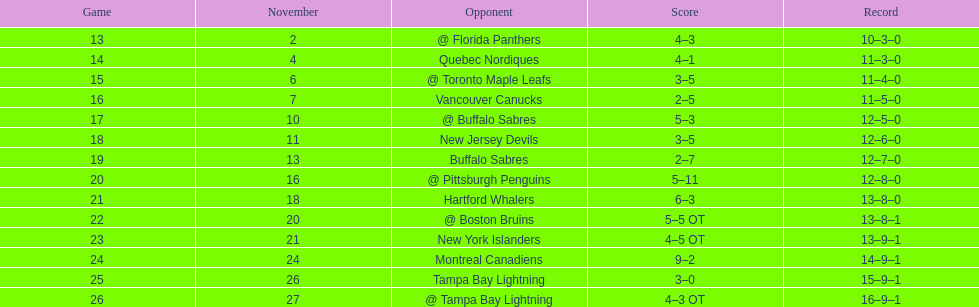The 1993-1994 flyers missed the playoffs again. how many consecutive seasons up until 93-94 did the flyers miss the playoffs? 5. Parse the table in full. {'header': ['Game', 'November', 'Opponent', 'Score', 'Record'], 'rows': [['13', '2', '@ Florida Panthers', '4–3', '10–3–0'], ['14', '4', 'Quebec Nordiques', '4–1', '11–3–0'], ['15', '6', '@ Toronto Maple Leafs', '3–5', '11–4–0'], ['16', '7', 'Vancouver Canucks', '2–5', '11–5–0'], ['17', '10', '@ Buffalo Sabres', '5–3', '12–5–0'], ['18', '11', 'New Jersey Devils', '3–5', '12–6–0'], ['19', '13', 'Buffalo Sabres', '2–7', '12–7–0'], ['20', '16', '@ Pittsburgh Penguins', '5–11', '12–8–0'], ['21', '18', 'Hartford Whalers', '6–3', '13–8–0'], ['22', '20', '@ Boston Bruins', '5–5 OT', '13–8–1'], ['23', '21', 'New York Islanders', '4–5 OT', '13–9–1'], ['24', '24', 'Montreal Canadiens', '9–2', '14–9–1'], ['25', '26', 'Tampa Bay Lightning', '3–0', '15–9–1'], ['26', '27', '@ Tampa Bay Lightning', '4–3 OT', '16–9–1']]} 